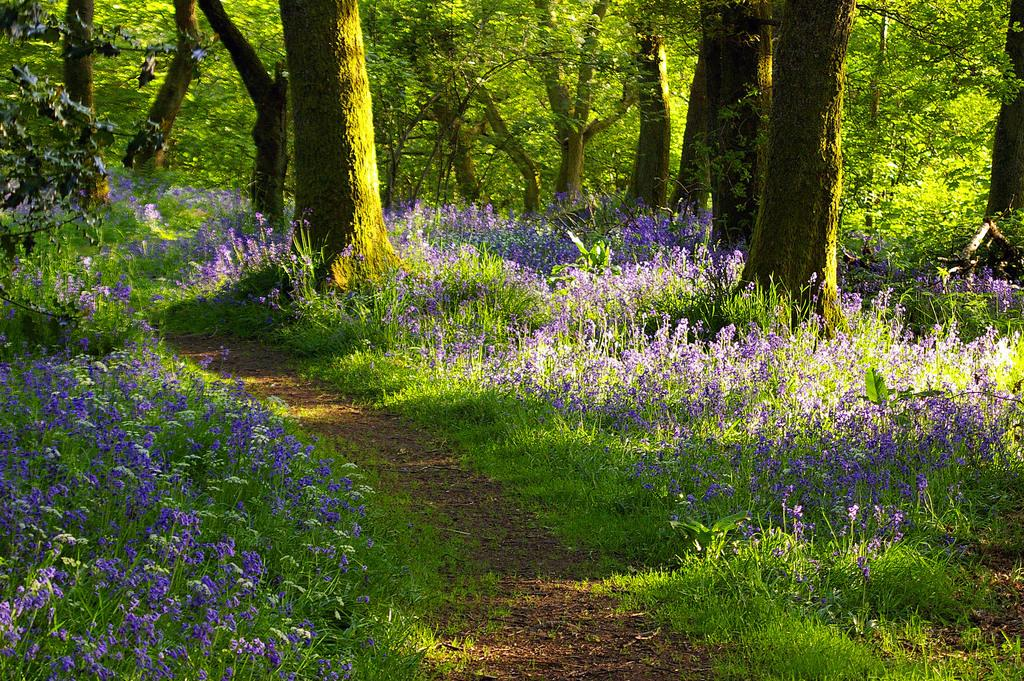What type of vegetation can be seen in the background of the image? There are trees in the background of the image. What other types of vegetation are present in the image? There are plants and flowers in the image. What is the purpose of the walkway in the image? The walkway in the image provides a path for people to walk on. What type of hydrant can be seen in the image? There is no hydrant present in the image. What does the taste of the flowers in the image suggest? The image does not provide any information about the taste of the flowers, as taste is not a visual characteristic. 